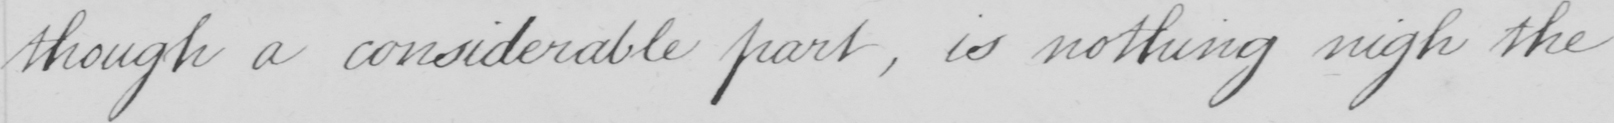Can you tell me what this handwritten text says? though a considerable part  , is nothing nigh the 